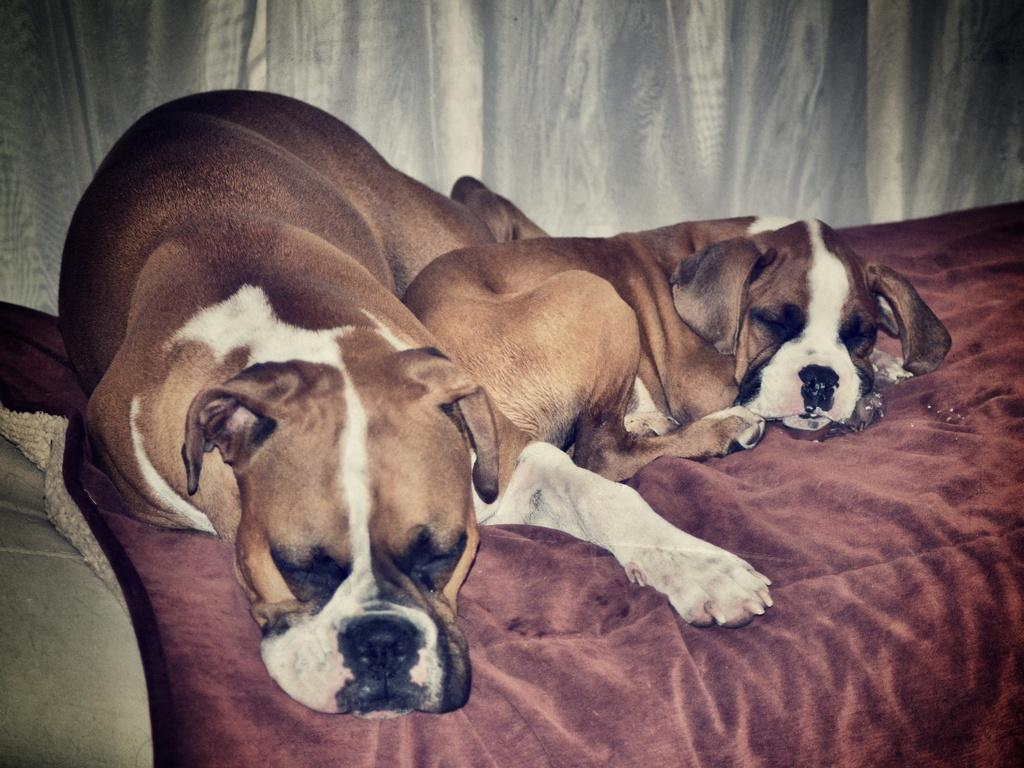How many dogs are in the image? There are two dogs in the image. What color are the dogs? The dogs are brown in color. What is the dogs' location in the image? The dogs are on a maroon-colored bed sheet. What can be seen in the background of the image? There is an ash-colored curtain in the background of the image. What type of amusement can be seen in the image? There is no amusement present in the image; it features two brown dogs on a maroon-colored bed sheet. How much tax is being paid for the dogs in the image? There is no indication of tax payment in the image; it simply shows two dogs on a bed sheet. 